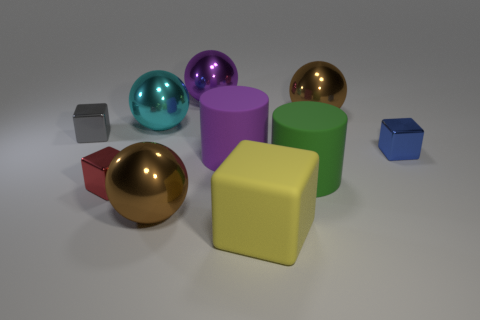There is a large metallic object in front of the cyan ball; is its color the same as the big metallic sphere that is to the right of the large purple ball?
Offer a very short reply. Yes. Does the green cylinder have the same size as the metallic block right of the big cyan shiny sphere?
Give a very brief answer. No. Does the brown thing that is to the left of the green rubber thing have the same size as the gray thing?
Provide a succinct answer. No. Is the number of cyan balls to the right of the purple rubber thing greater than the number of rubber objects?
Give a very brief answer. No. Is the shape of the purple metallic thing the same as the big brown shiny thing in front of the blue shiny object?
Provide a succinct answer. Yes. How many tiny objects are either cylinders or spheres?
Offer a terse response. 0. What is the color of the small thing right of the large brown metallic ball that is on the right side of the green matte object?
Your response must be concise. Blue. Is the yellow object made of the same material as the large brown object in front of the small red block?
Give a very brief answer. No. There is a green cylinder behind the yellow matte thing; what material is it?
Offer a very short reply. Rubber. Is the number of purple balls that are to the left of the big cyan shiny object the same as the number of small red metal blocks?
Give a very brief answer. No. 